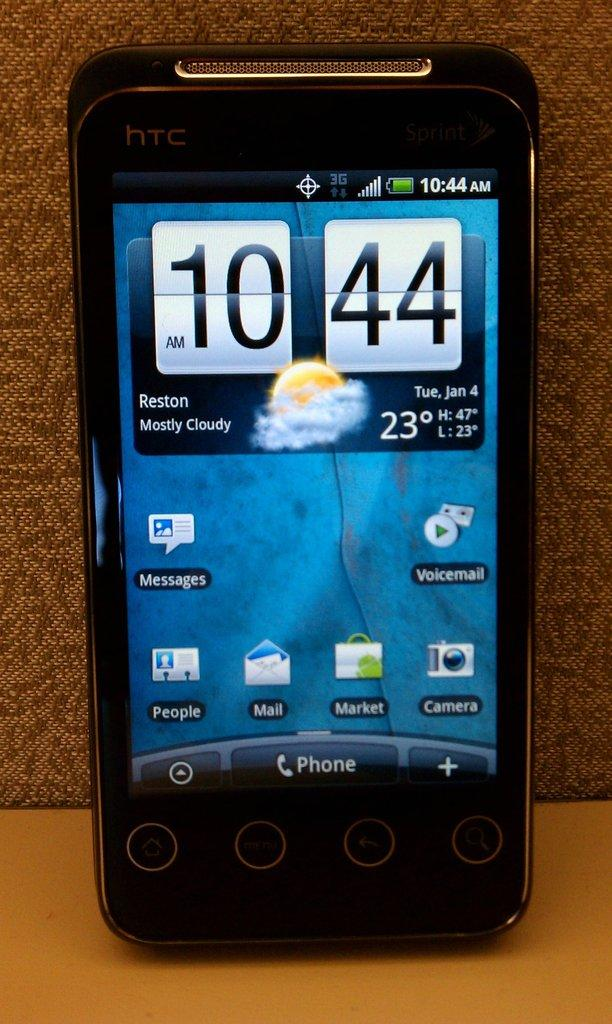<image>
Write a terse but informative summary of the picture. An HTC smartphone showing the time and weather forecast on the homescreen. 